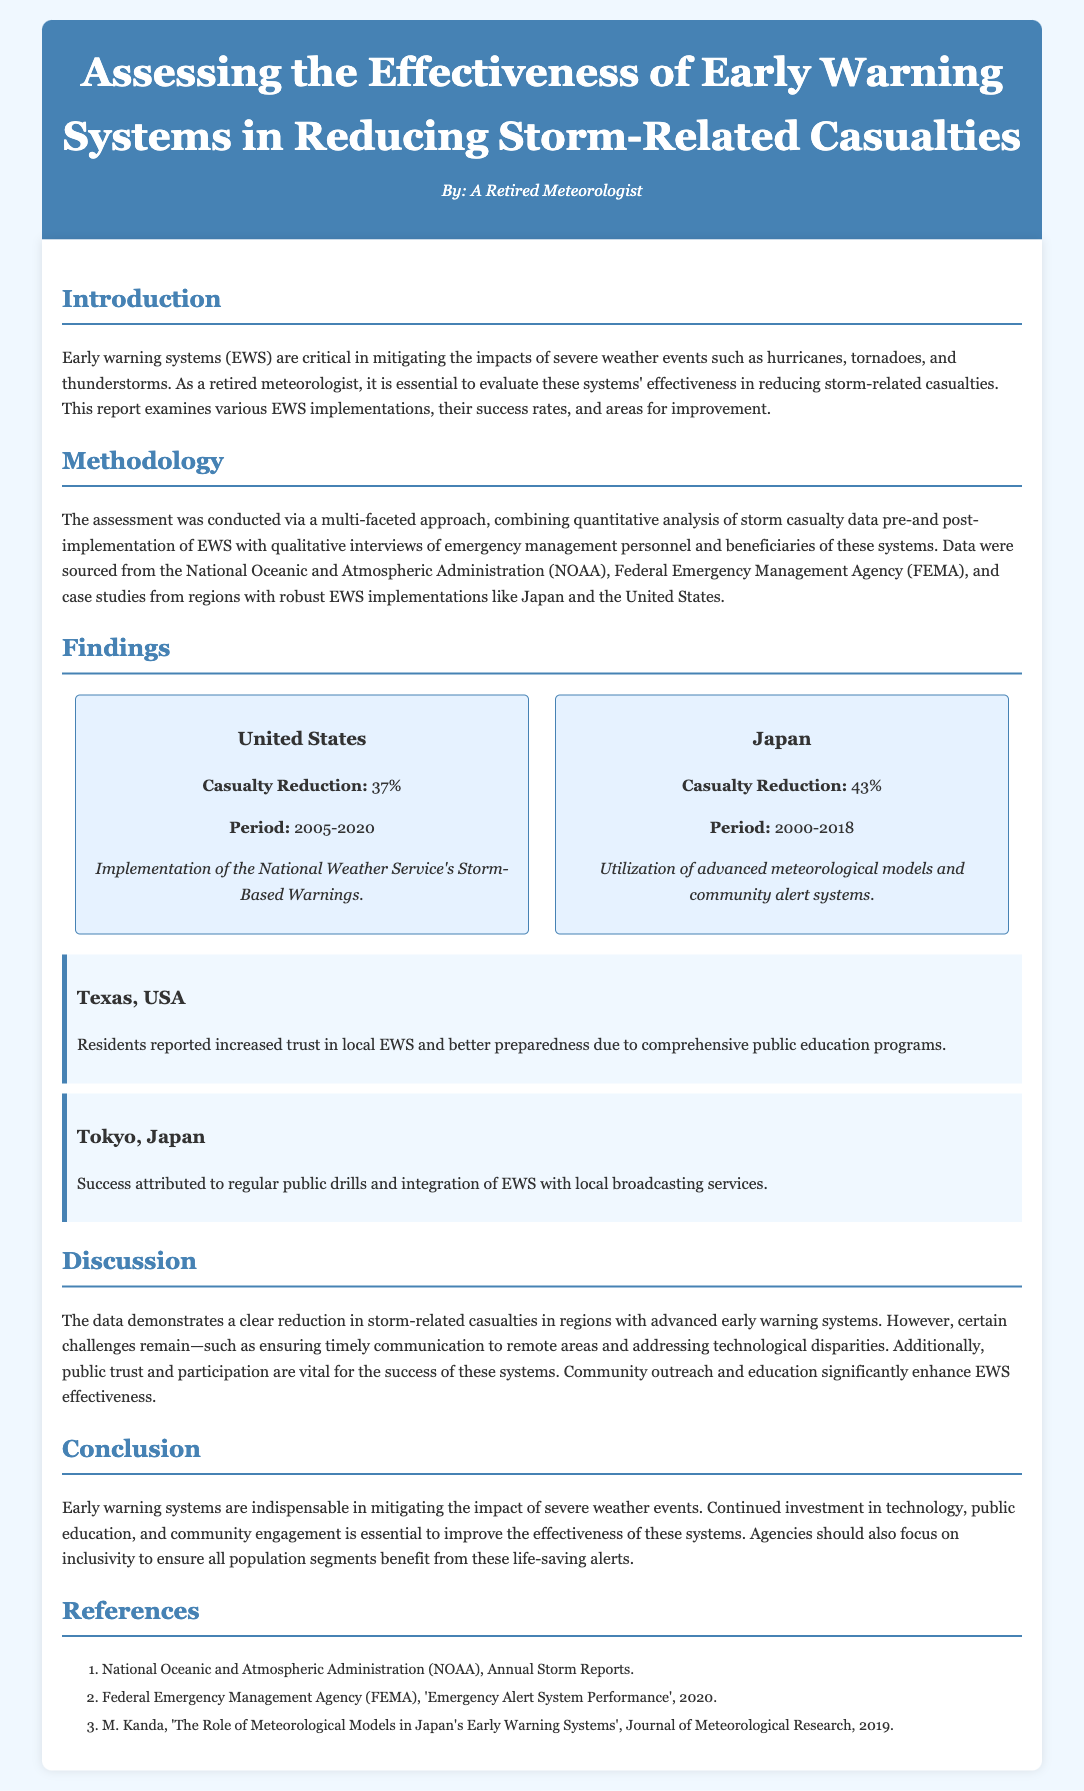what is the primary focus of the report? The report evaluates the effectiveness of early warning systems in reducing storm-related casualties.
Answer: effectiveness of early warning systems what period did the United States data cover? The United States data spans from 2005 to 2020.
Answer: 2005-2020 what percentage of casualty reduction was reported in Japan? Japan's early warning systems resulted in a 43% reduction in casualties.
Answer: 43% which system was implemented in Texas, USA? The report mentions the National Weather Service's Storm-Based Warnings for the United States.
Answer: Storm-Based Warnings what is one challenge highlighted in the discussion? The document notes that ensuring timely communication to remote areas is a challenge.
Answer: timely communication how did community outreach impact EWS effectiveness? The document states that community outreach and education significantly enhance the effectiveness of early warning systems.
Answer: significantly enhance effectiveness who are the key agencies mentioned in the report? The report references the National Oceanic and Atmospheric Administration and the Federal Emergency Management Agency.
Answer: NOAA and FEMA what is a noted success factor in Tokyo, Japan? Regular public drills and integration of EWS with local broadcasting services contributed to success in Tokyo.
Answer: public drills what type of research methodology was used in the assessment? The assessment combined quantitative analysis with qualitative interviews.
Answer: quantitative and qualitative analysis 